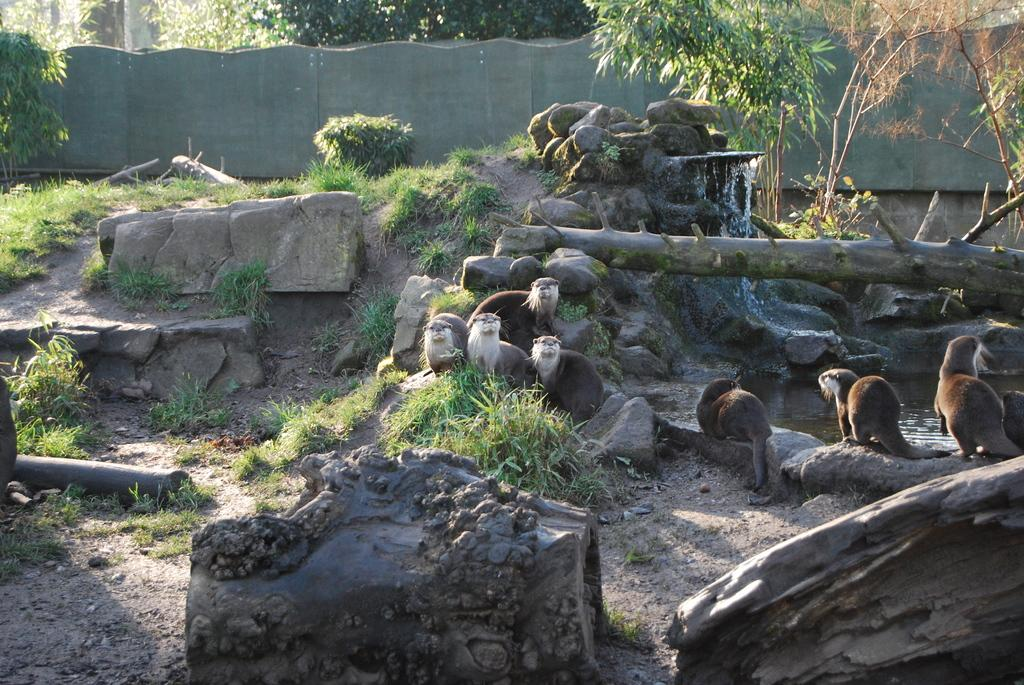What types of animals are present in the image? There are animals in the image, but their specific species cannot be determined from the provided facts. Where are the animals located in the image? The animals are sitting and standing on rocks, shrubs, the ground, a wall, and trees in the image. Who is the expert on the fowl in the image? There is no mention of an expert or fowl in the image, so it is not possible to answer that question. 